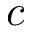Convert formula to latex. <formula><loc_0><loc_0><loc_500><loc_500>c</formula> 